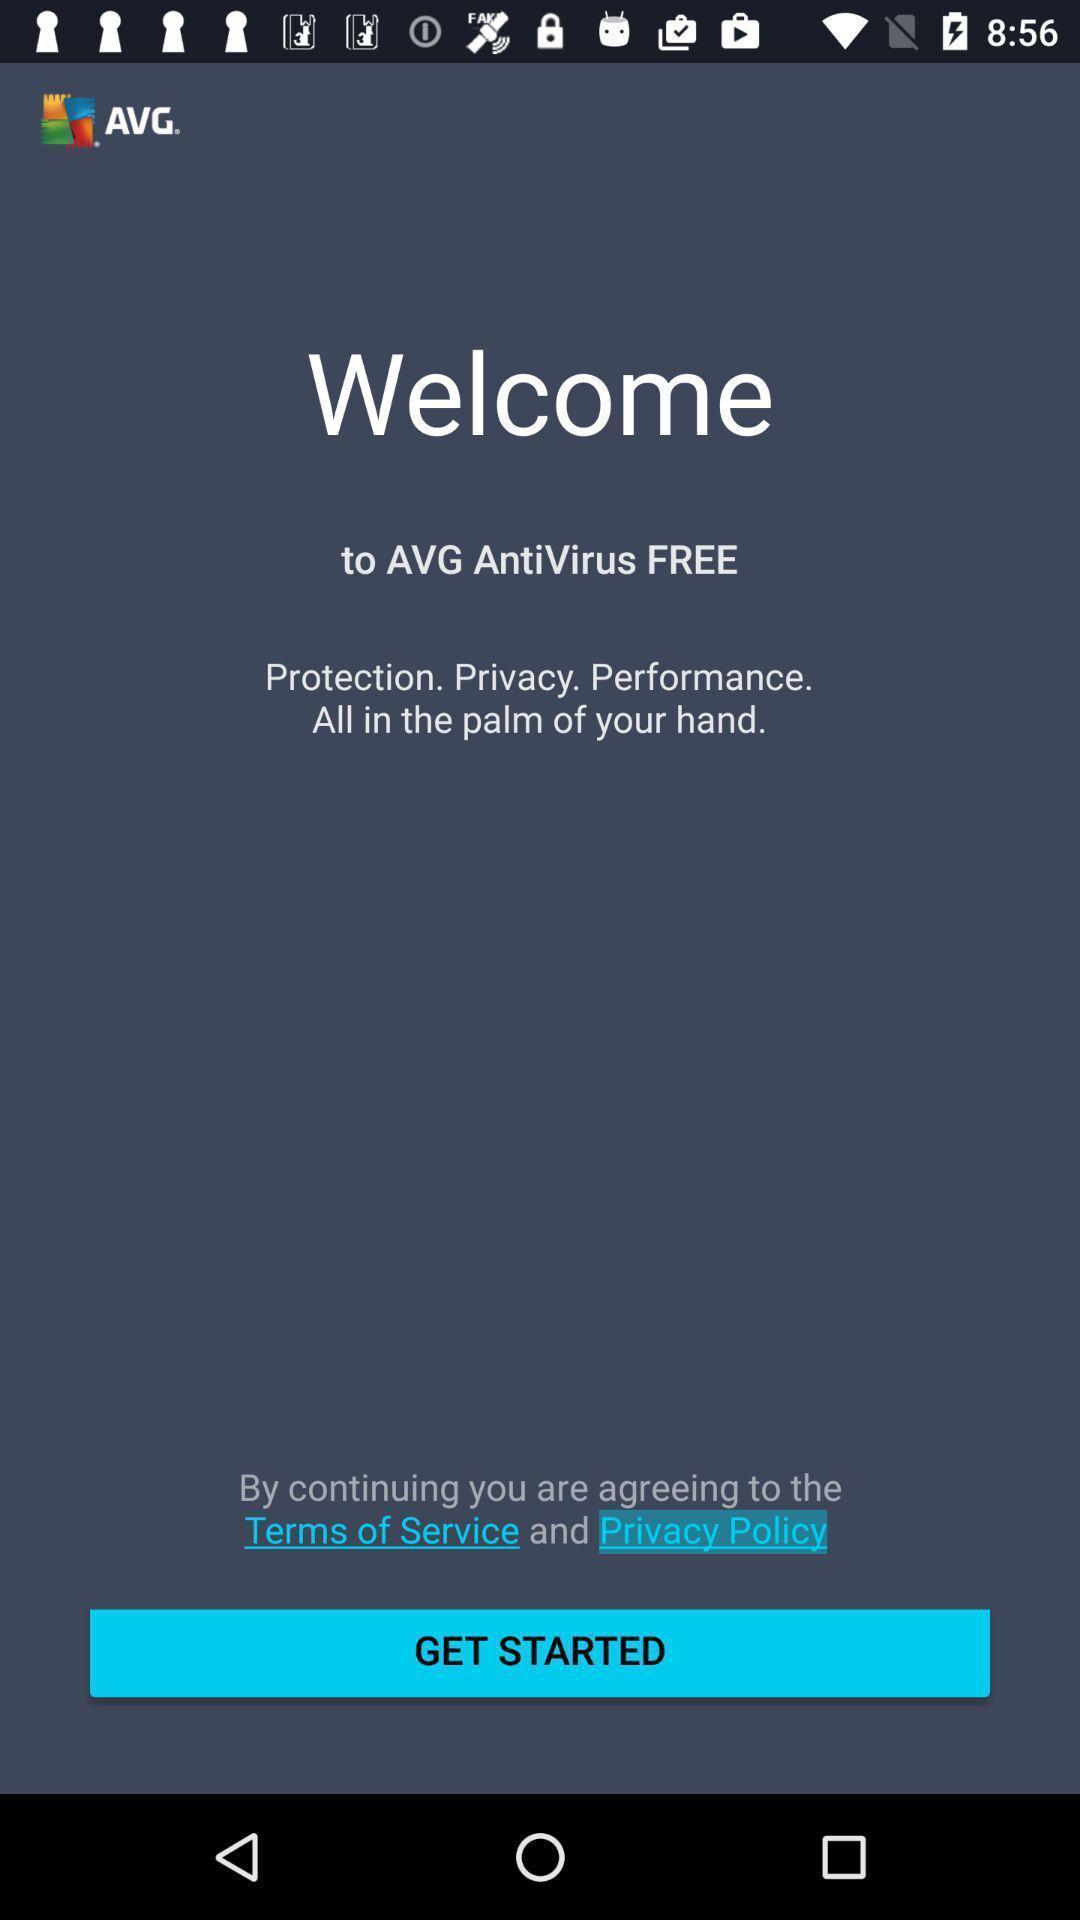Describe the content in this image. Welcome page of the app. 